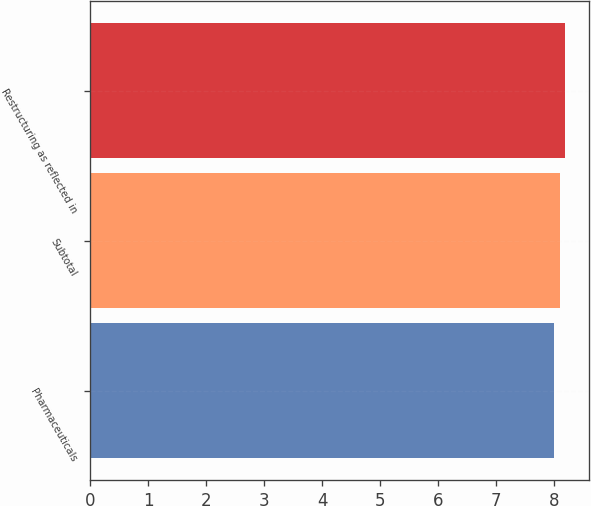<chart> <loc_0><loc_0><loc_500><loc_500><bar_chart><fcel>Pharmaceuticals<fcel>Subtotal<fcel>Restructuring as reflected in<nl><fcel>8<fcel>8.1<fcel>8.2<nl></chart> 